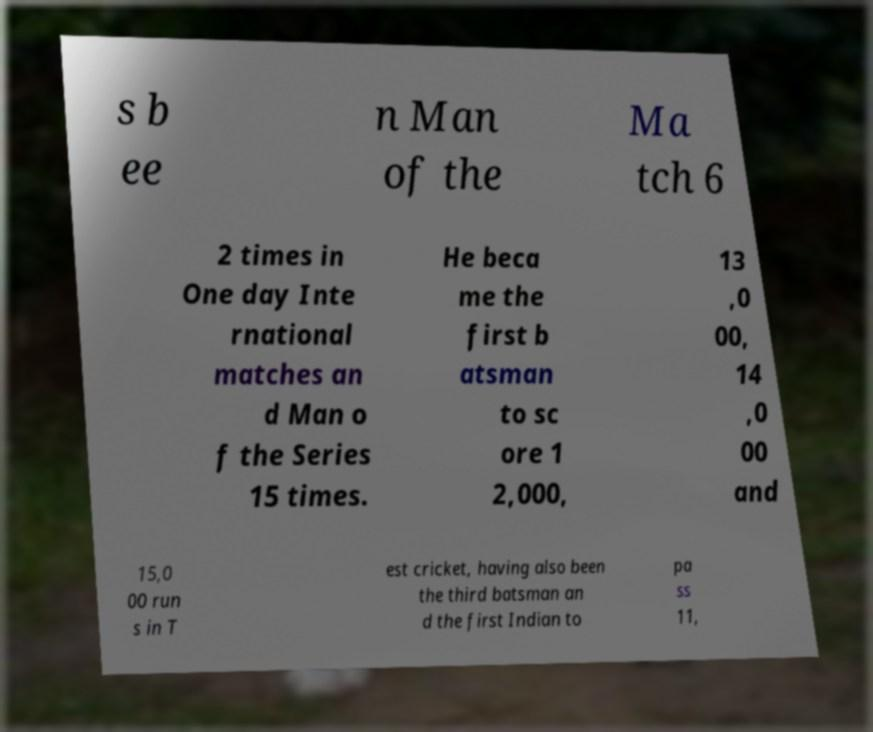For documentation purposes, I need the text within this image transcribed. Could you provide that? s b ee n Man of the Ma tch 6 2 times in One day Inte rnational matches an d Man o f the Series 15 times. He beca me the first b atsman to sc ore 1 2,000, 13 ,0 00, 14 ,0 00 and 15,0 00 run s in T est cricket, having also been the third batsman an d the first Indian to pa ss 11, 